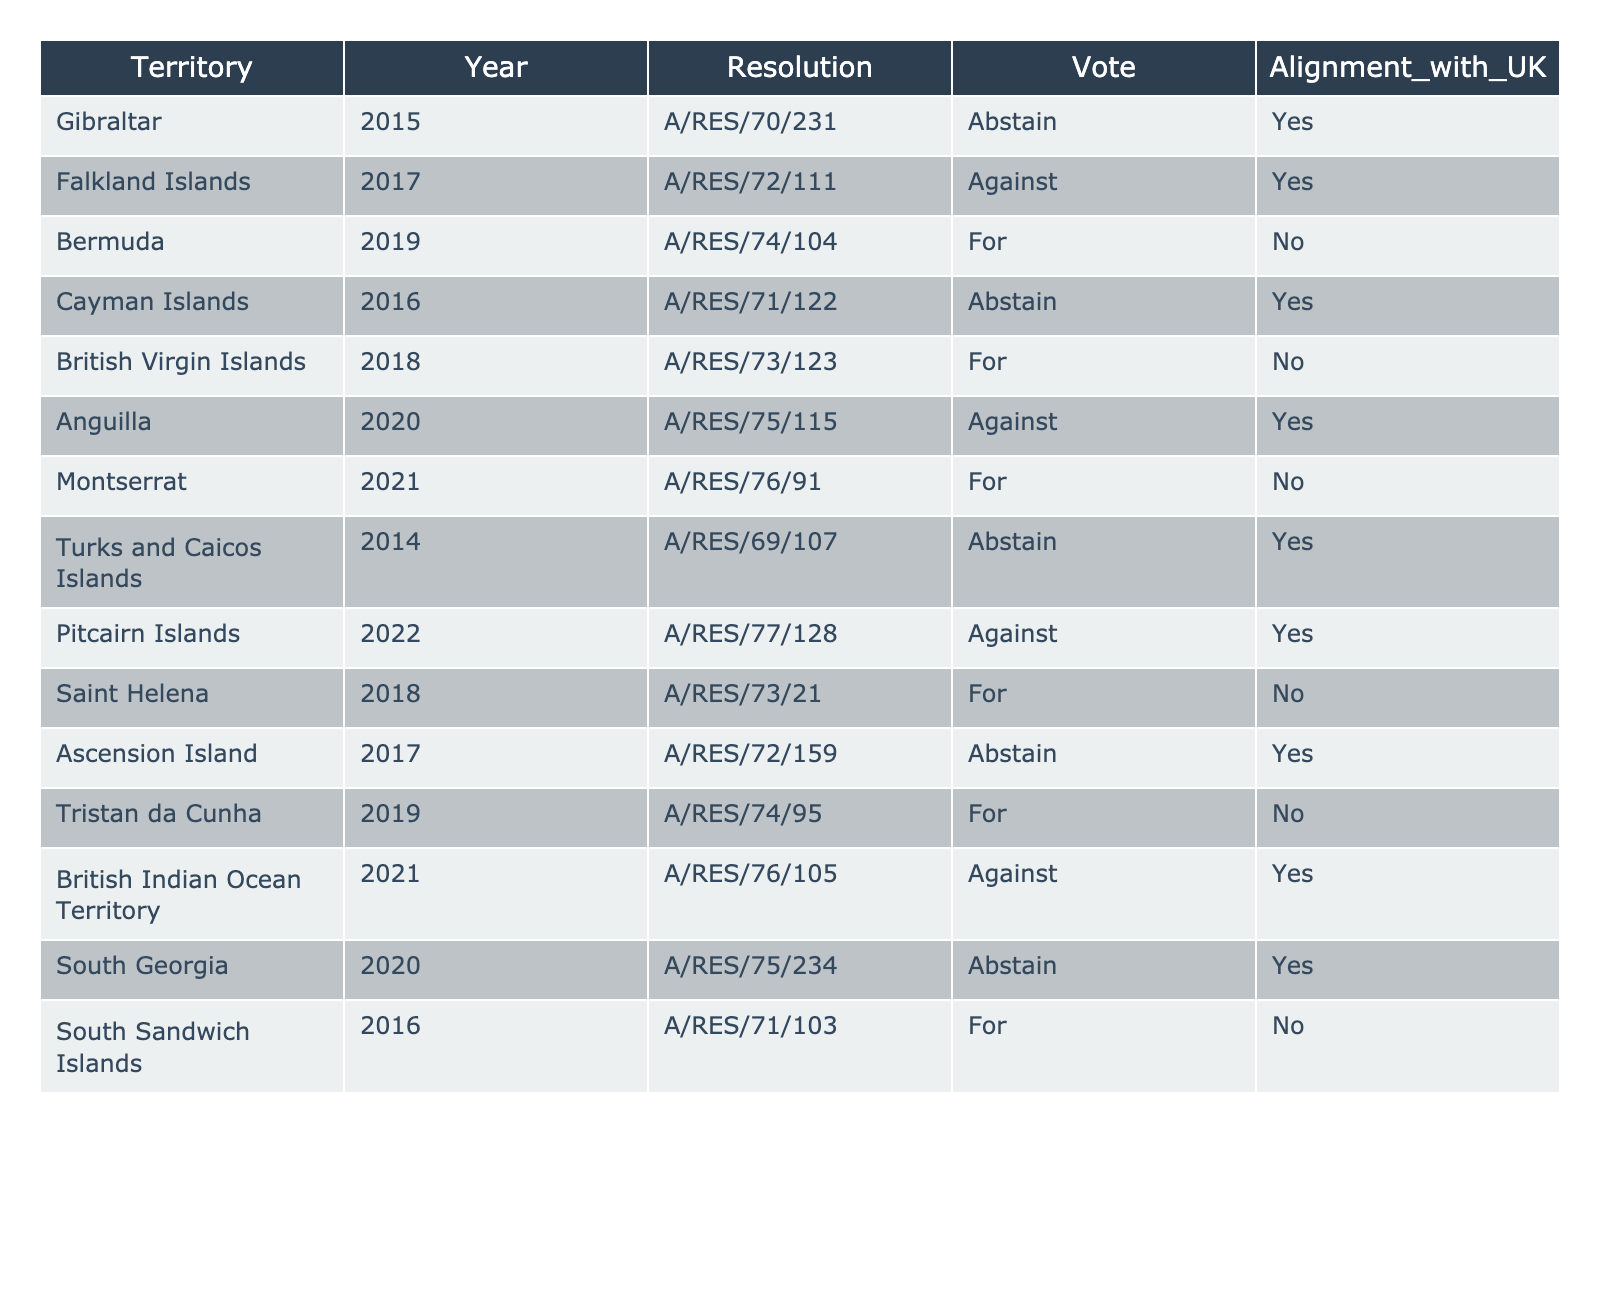What was the vote of the Cayman Islands in the 2016 resolution? Referring to the table, the Cayman Islands voted "Abstain" in the resolution A/RES/71/122 from 2016.
Answer: Abstain How many territories voted "For" in their respective resolutions? The table shows three territories voted "For" — Bermuda, British Virgin Islands, Saint Helena, and Tristan da Cunha. Therefore, the count is four territories.
Answer: 4 Did Gibraltar align with the UK's position in 2015? Looking at the 2015 resolution for Gibraltar, it shows an alignment with the UK ("Yes") even though the vote was an "Abstain".
Answer: Yes What percentage of the resolutions resulted in an "Against" vote from the territories? There were 14 resolutions in total; out of these, 4 resulted in an "Against" vote (Falkland Islands, Anguilla, Pitcairn Islands, British Indian Ocean Territory). To get the percentage, calculate (4/14) * 100 = approximately 28.57%.
Answer: 28.57% Which territory had the most recent "For" vote? The last occurrence of a "For" vote is for Montserrat in the resolution A/RES/76/91 in 2021.
Answer: Montserrat How many territories did not align with the UK in their votes? There are four territories listed in the table that did not align with the UK: Bermuda, British Virgin Islands, Saint Helena, and Tristan da Cunha.
Answer: 4 Did any territory vote "For" while aligning with the UK? Referring to the data, the territories that voted "For" were Bermuda, British Virgin Islands, Saint Helena, and Tristan da Cunha, and all of them did not align with the UK. Hence, no territory voted "For" while aligning with the UK.
Answer: No Which territory has the most diverse voting pattern in terms of votes across resolutions? By inspecting the table, Anguilla and Falkland Islands voted "Against" in different years, while several territories only abstained. Therefore, Falkland Islands with diverse voting patterns in "Against" while others mainly voted "For" or "Abstain".
Answer: Falkland Islands 